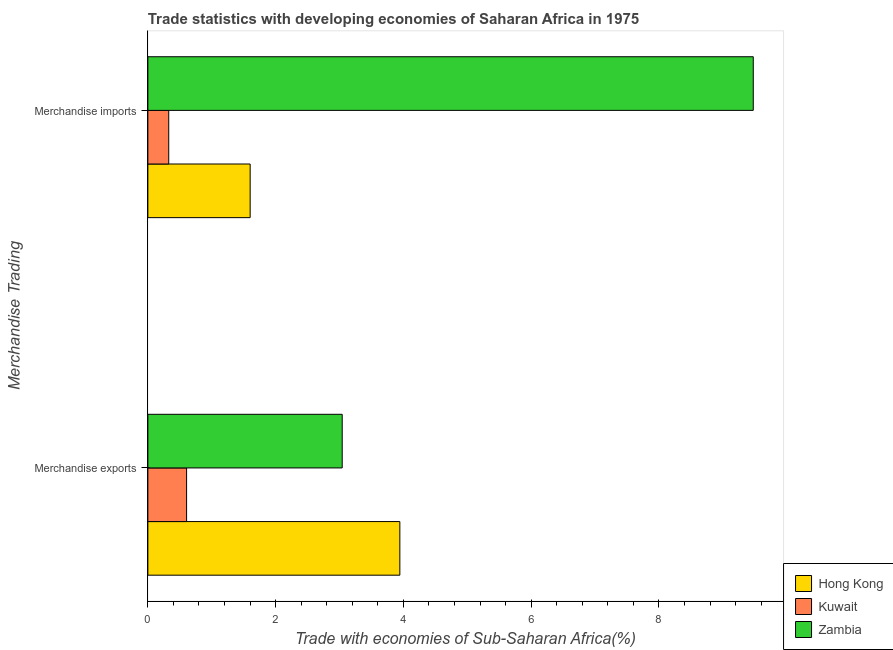Are the number of bars per tick equal to the number of legend labels?
Ensure brevity in your answer.  Yes. What is the label of the 2nd group of bars from the top?
Keep it short and to the point. Merchandise exports. What is the merchandise imports in Kuwait?
Offer a very short reply. 0.33. Across all countries, what is the maximum merchandise exports?
Provide a succinct answer. 3.94. Across all countries, what is the minimum merchandise exports?
Provide a short and direct response. 0.61. In which country was the merchandise imports maximum?
Keep it short and to the point. Zambia. In which country was the merchandise imports minimum?
Provide a succinct answer. Kuwait. What is the total merchandise imports in the graph?
Your answer should be compact. 11.4. What is the difference between the merchandise imports in Kuwait and that in Hong Kong?
Provide a succinct answer. -1.27. What is the difference between the merchandise imports in Hong Kong and the merchandise exports in Kuwait?
Your response must be concise. 0.99. What is the average merchandise imports per country?
Make the answer very short. 3.8. What is the difference between the merchandise imports and merchandise exports in Hong Kong?
Give a very brief answer. -2.34. What is the ratio of the merchandise exports in Hong Kong to that in Zambia?
Your answer should be compact. 1.3. What does the 3rd bar from the top in Merchandise imports represents?
Give a very brief answer. Hong Kong. What does the 3rd bar from the bottom in Merchandise imports represents?
Your answer should be very brief. Zambia. How many countries are there in the graph?
Your response must be concise. 3. What is the difference between two consecutive major ticks on the X-axis?
Offer a very short reply. 2. Does the graph contain grids?
Your answer should be very brief. No. Where does the legend appear in the graph?
Offer a terse response. Bottom right. How many legend labels are there?
Offer a terse response. 3. How are the legend labels stacked?
Offer a very short reply. Vertical. What is the title of the graph?
Provide a succinct answer. Trade statistics with developing economies of Saharan Africa in 1975. Does "Israel" appear as one of the legend labels in the graph?
Offer a terse response. No. What is the label or title of the X-axis?
Your response must be concise. Trade with economies of Sub-Saharan Africa(%). What is the label or title of the Y-axis?
Provide a short and direct response. Merchandise Trading. What is the Trade with economies of Sub-Saharan Africa(%) in Hong Kong in Merchandise exports?
Keep it short and to the point. 3.94. What is the Trade with economies of Sub-Saharan Africa(%) of Kuwait in Merchandise exports?
Ensure brevity in your answer.  0.61. What is the Trade with economies of Sub-Saharan Africa(%) of Zambia in Merchandise exports?
Your response must be concise. 3.04. What is the Trade with economies of Sub-Saharan Africa(%) in Hong Kong in Merchandise imports?
Your answer should be very brief. 1.6. What is the Trade with economies of Sub-Saharan Africa(%) of Kuwait in Merchandise imports?
Keep it short and to the point. 0.33. What is the Trade with economies of Sub-Saharan Africa(%) of Zambia in Merchandise imports?
Your response must be concise. 9.48. Across all Merchandise Trading, what is the maximum Trade with economies of Sub-Saharan Africa(%) in Hong Kong?
Provide a succinct answer. 3.94. Across all Merchandise Trading, what is the maximum Trade with economies of Sub-Saharan Africa(%) of Kuwait?
Ensure brevity in your answer.  0.61. Across all Merchandise Trading, what is the maximum Trade with economies of Sub-Saharan Africa(%) of Zambia?
Your answer should be very brief. 9.48. Across all Merchandise Trading, what is the minimum Trade with economies of Sub-Saharan Africa(%) of Hong Kong?
Offer a very short reply. 1.6. Across all Merchandise Trading, what is the minimum Trade with economies of Sub-Saharan Africa(%) of Kuwait?
Your answer should be compact. 0.33. Across all Merchandise Trading, what is the minimum Trade with economies of Sub-Saharan Africa(%) in Zambia?
Provide a short and direct response. 3.04. What is the total Trade with economies of Sub-Saharan Africa(%) of Hong Kong in the graph?
Make the answer very short. 5.55. What is the total Trade with economies of Sub-Saharan Africa(%) of Kuwait in the graph?
Make the answer very short. 0.93. What is the total Trade with economies of Sub-Saharan Africa(%) of Zambia in the graph?
Offer a terse response. 12.52. What is the difference between the Trade with economies of Sub-Saharan Africa(%) in Hong Kong in Merchandise exports and that in Merchandise imports?
Offer a terse response. 2.34. What is the difference between the Trade with economies of Sub-Saharan Africa(%) in Kuwait in Merchandise exports and that in Merchandise imports?
Your response must be concise. 0.28. What is the difference between the Trade with economies of Sub-Saharan Africa(%) of Zambia in Merchandise exports and that in Merchandise imports?
Keep it short and to the point. -6.43. What is the difference between the Trade with economies of Sub-Saharan Africa(%) in Hong Kong in Merchandise exports and the Trade with economies of Sub-Saharan Africa(%) in Kuwait in Merchandise imports?
Offer a very short reply. 3.62. What is the difference between the Trade with economies of Sub-Saharan Africa(%) of Hong Kong in Merchandise exports and the Trade with economies of Sub-Saharan Africa(%) of Zambia in Merchandise imports?
Offer a terse response. -5.53. What is the difference between the Trade with economies of Sub-Saharan Africa(%) of Kuwait in Merchandise exports and the Trade with economies of Sub-Saharan Africa(%) of Zambia in Merchandise imports?
Provide a short and direct response. -8.87. What is the average Trade with economies of Sub-Saharan Africa(%) of Hong Kong per Merchandise Trading?
Your answer should be compact. 2.77. What is the average Trade with economies of Sub-Saharan Africa(%) in Kuwait per Merchandise Trading?
Your response must be concise. 0.47. What is the average Trade with economies of Sub-Saharan Africa(%) in Zambia per Merchandise Trading?
Provide a short and direct response. 6.26. What is the difference between the Trade with economies of Sub-Saharan Africa(%) in Hong Kong and Trade with economies of Sub-Saharan Africa(%) in Kuwait in Merchandise exports?
Your answer should be very brief. 3.34. What is the difference between the Trade with economies of Sub-Saharan Africa(%) in Hong Kong and Trade with economies of Sub-Saharan Africa(%) in Zambia in Merchandise exports?
Provide a succinct answer. 0.9. What is the difference between the Trade with economies of Sub-Saharan Africa(%) in Kuwait and Trade with economies of Sub-Saharan Africa(%) in Zambia in Merchandise exports?
Keep it short and to the point. -2.44. What is the difference between the Trade with economies of Sub-Saharan Africa(%) of Hong Kong and Trade with economies of Sub-Saharan Africa(%) of Kuwait in Merchandise imports?
Provide a short and direct response. 1.27. What is the difference between the Trade with economies of Sub-Saharan Africa(%) of Hong Kong and Trade with economies of Sub-Saharan Africa(%) of Zambia in Merchandise imports?
Your answer should be compact. -7.87. What is the difference between the Trade with economies of Sub-Saharan Africa(%) in Kuwait and Trade with economies of Sub-Saharan Africa(%) in Zambia in Merchandise imports?
Your answer should be compact. -9.15. What is the ratio of the Trade with economies of Sub-Saharan Africa(%) in Hong Kong in Merchandise exports to that in Merchandise imports?
Ensure brevity in your answer.  2.46. What is the ratio of the Trade with economies of Sub-Saharan Africa(%) in Kuwait in Merchandise exports to that in Merchandise imports?
Your answer should be very brief. 1.86. What is the ratio of the Trade with economies of Sub-Saharan Africa(%) of Zambia in Merchandise exports to that in Merchandise imports?
Ensure brevity in your answer.  0.32. What is the difference between the highest and the second highest Trade with economies of Sub-Saharan Africa(%) in Hong Kong?
Provide a succinct answer. 2.34. What is the difference between the highest and the second highest Trade with economies of Sub-Saharan Africa(%) of Kuwait?
Your answer should be very brief. 0.28. What is the difference between the highest and the second highest Trade with economies of Sub-Saharan Africa(%) of Zambia?
Make the answer very short. 6.43. What is the difference between the highest and the lowest Trade with economies of Sub-Saharan Africa(%) of Hong Kong?
Your answer should be compact. 2.34. What is the difference between the highest and the lowest Trade with economies of Sub-Saharan Africa(%) of Kuwait?
Ensure brevity in your answer.  0.28. What is the difference between the highest and the lowest Trade with economies of Sub-Saharan Africa(%) in Zambia?
Make the answer very short. 6.43. 